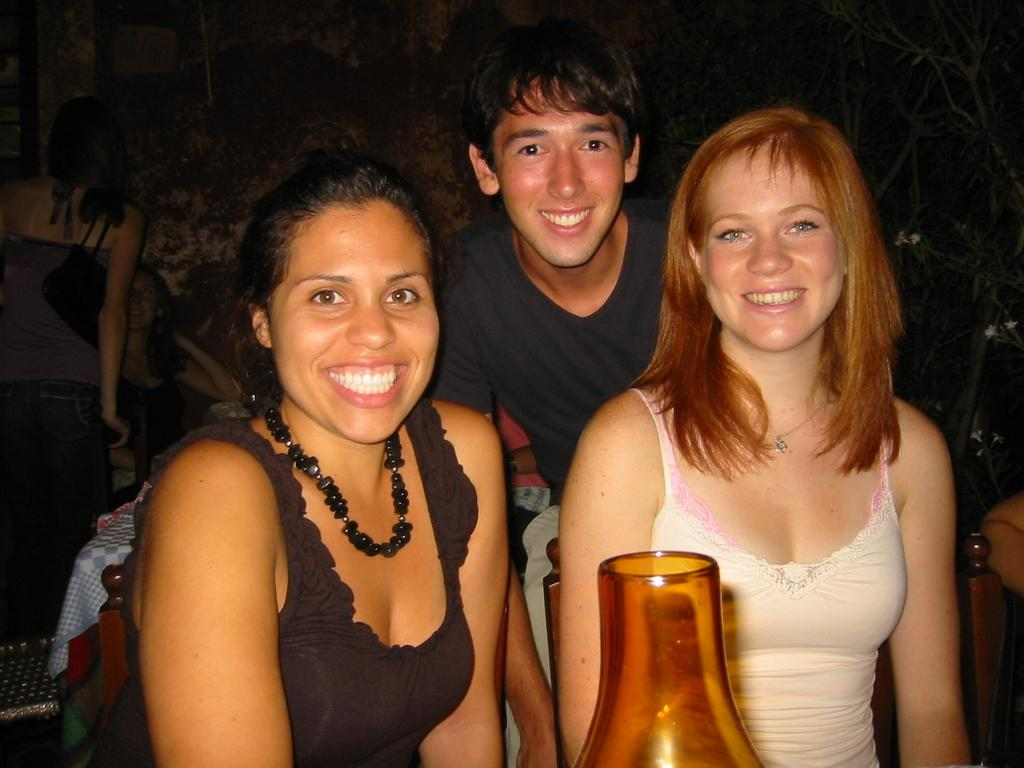How many people are in the image? There are two women and a boy in the image, making a total of three people. What is the facial expression of the people in the image? The women and the boy are smiling in the image. What object in the image has light? There is a jar with light in the image. How would you describe the lighting conditions in the image? The background of the image appears to be dark. What time of day is it in the image, considering the morning? The provided facts do not mention the time of day or any reference to morning. Therefore, we cannot determine the time of day from the image. 